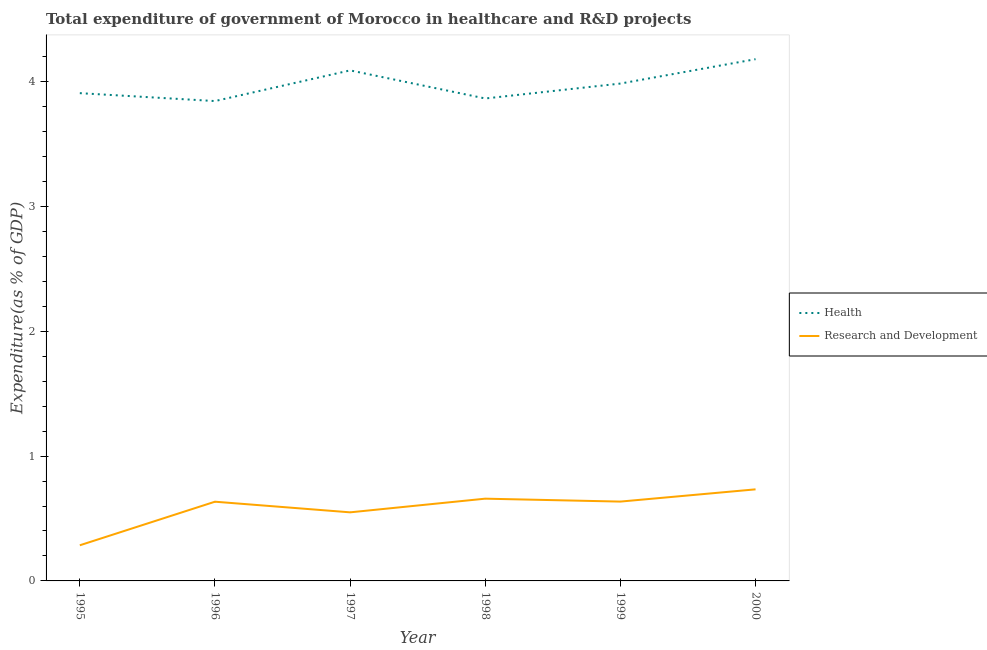What is the expenditure in healthcare in 1999?
Keep it short and to the point. 3.99. Across all years, what is the maximum expenditure in r&d?
Provide a short and direct response. 0.73. Across all years, what is the minimum expenditure in r&d?
Ensure brevity in your answer.  0.29. What is the total expenditure in healthcare in the graph?
Keep it short and to the point. 23.88. What is the difference between the expenditure in healthcare in 1998 and that in 2000?
Give a very brief answer. -0.31. What is the difference between the expenditure in r&d in 1998 and the expenditure in healthcare in 1999?
Ensure brevity in your answer.  -3.33. What is the average expenditure in healthcare per year?
Offer a very short reply. 3.98. In the year 1998, what is the difference between the expenditure in healthcare and expenditure in r&d?
Provide a short and direct response. 3.21. In how many years, is the expenditure in r&d greater than 0.6000000000000001 %?
Offer a terse response. 4. What is the ratio of the expenditure in healthcare in 1998 to that in 2000?
Make the answer very short. 0.92. What is the difference between the highest and the second highest expenditure in healthcare?
Make the answer very short. 0.09. What is the difference between the highest and the lowest expenditure in healthcare?
Make the answer very short. 0.34. In how many years, is the expenditure in r&d greater than the average expenditure in r&d taken over all years?
Your response must be concise. 4. Does the expenditure in healthcare monotonically increase over the years?
Give a very brief answer. No. Is the expenditure in healthcare strictly less than the expenditure in r&d over the years?
Make the answer very short. No. How many years are there in the graph?
Make the answer very short. 6. What is the difference between two consecutive major ticks on the Y-axis?
Give a very brief answer. 1. Where does the legend appear in the graph?
Your answer should be very brief. Center right. What is the title of the graph?
Offer a very short reply. Total expenditure of government of Morocco in healthcare and R&D projects. What is the label or title of the X-axis?
Your answer should be very brief. Year. What is the label or title of the Y-axis?
Offer a terse response. Expenditure(as % of GDP). What is the Expenditure(as % of GDP) of Health in 1995?
Offer a terse response. 3.91. What is the Expenditure(as % of GDP) of Research and Development in 1995?
Offer a very short reply. 0.29. What is the Expenditure(as % of GDP) in Health in 1996?
Provide a short and direct response. 3.84. What is the Expenditure(as % of GDP) in Research and Development in 1996?
Offer a very short reply. 0.63. What is the Expenditure(as % of GDP) in Health in 1997?
Your answer should be very brief. 4.09. What is the Expenditure(as % of GDP) of Research and Development in 1997?
Your answer should be compact. 0.55. What is the Expenditure(as % of GDP) of Health in 1998?
Your answer should be compact. 3.87. What is the Expenditure(as % of GDP) in Research and Development in 1998?
Your response must be concise. 0.66. What is the Expenditure(as % of GDP) of Health in 1999?
Your answer should be very brief. 3.99. What is the Expenditure(as % of GDP) in Research and Development in 1999?
Keep it short and to the point. 0.64. What is the Expenditure(as % of GDP) in Health in 2000?
Your response must be concise. 4.18. What is the Expenditure(as % of GDP) of Research and Development in 2000?
Your answer should be compact. 0.73. Across all years, what is the maximum Expenditure(as % of GDP) in Health?
Offer a very short reply. 4.18. Across all years, what is the maximum Expenditure(as % of GDP) of Research and Development?
Ensure brevity in your answer.  0.73. Across all years, what is the minimum Expenditure(as % of GDP) of Health?
Offer a very short reply. 3.84. Across all years, what is the minimum Expenditure(as % of GDP) in Research and Development?
Provide a succinct answer. 0.29. What is the total Expenditure(as % of GDP) of Health in the graph?
Provide a short and direct response. 23.88. What is the total Expenditure(as % of GDP) of Research and Development in the graph?
Your answer should be very brief. 3.5. What is the difference between the Expenditure(as % of GDP) in Health in 1995 and that in 1996?
Offer a very short reply. 0.06. What is the difference between the Expenditure(as % of GDP) of Research and Development in 1995 and that in 1996?
Your answer should be compact. -0.35. What is the difference between the Expenditure(as % of GDP) in Health in 1995 and that in 1997?
Offer a terse response. -0.18. What is the difference between the Expenditure(as % of GDP) in Research and Development in 1995 and that in 1997?
Give a very brief answer. -0.26. What is the difference between the Expenditure(as % of GDP) in Health in 1995 and that in 1998?
Offer a terse response. 0.04. What is the difference between the Expenditure(as % of GDP) of Research and Development in 1995 and that in 1998?
Your response must be concise. -0.37. What is the difference between the Expenditure(as % of GDP) in Health in 1995 and that in 1999?
Your answer should be very brief. -0.08. What is the difference between the Expenditure(as % of GDP) in Research and Development in 1995 and that in 1999?
Ensure brevity in your answer.  -0.35. What is the difference between the Expenditure(as % of GDP) of Health in 1995 and that in 2000?
Your answer should be very brief. -0.27. What is the difference between the Expenditure(as % of GDP) in Research and Development in 1995 and that in 2000?
Your response must be concise. -0.45. What is the difference between the Expenditure(as % of GDP) of Health in 1996 and that in 1997?
Give a very brief answer. -0.25. What is the difference between the Expenditure(as % of GDP) of Research and Development in 1996 and that in 1997?
Provide a short and direct response. 0.09. What is the difference between the Expenditure(as % of GDP) in Health in 1996 and that in 1998?
Your answer should be very brief. -0.02. What is the difference between the Expenditure(as % of GDP) of Research and Development in 1996 and that in 1998?
Offer a terse response. -0.02. What is the difference between the Expenditure(as % of GDP) in Health in 1996 and that in 1999?
Give a very brief answer. -0.14. What is the difference between the Expenditure(as % of GDP) in Research and Development in 1996 and that in 1999?
Your answer should be compact. -0. What is the difference between the Expenditure(as % of GDP) of Health in 1996 and that in 2000?
Your answer should be compact. -0.34. What is the difference between the Expenditure(as % of GDP) in Research and Development in 1996 and that in 2000?
Ensure brevity in your answer.  -0.1. What is the difference between the Expenditure(as % of GDP) of Health in 1997 and that in 1998?
Your response must be concise. 0.23. What is the difference between the Expenditure(as % of GDP) in Research and Development in 1997 and that in 1998?
Give a very brief answer. -0.11. What is the difference between the Expenditure(as % of GDP) in Health in 1997 and that in 1999?
Offer a very short reply. 0.11. What is the difference between the Expenditure(as % of GDP) of Research and Development in 1997 and that in 1999?
Offer a very short reply. -0.09. What is the difference between the Expenditure(as % of GDP) of Health in 1997 and that in 2000?
Provide a short and direct response. -0.09. What is the difference between the Expenditure(as % of GDP) of Research and Development in 1997 and that in 2000?
Your answer should be compact. -0.18. What is the difference between the Expenditure(as % of GDP) of Health in 1998 and that in 1999?
Provide a succinct answer. -0.12. What is the difference between the Expenditure(as % of GDP) of Research and Development in 1998 and that in 1999?
Keep it short and to the point. 0.02. What is the difference between the Expenditure(as % of GDP) in Health in 1998 and that in 2000?
Offer a terse response. -0.31. What is the difference between the Expenditure(as % of GDP) of Research and Development in 1998 and that in 2000?
Your answer should be very brief. -0.07. What is the difference between the Expenditure(as % of GDP) in Health in 1999 and that in 2000?
Keep it short and to the point. -0.2. What is the difference between the Expenditure(as % of GDP) of Research and Development in 1999 and that in 2000?
Your response must be concise. -0.1. What is the difference between the Expenditure(as % of GDP) in Health in 1995 and the Expenditure(as % of GDP) in Research and Development in 1996?
Provide a short and direct response. 3.27. What is the difference between the Expenditure(as % of GDP) of Health in 1995 and the Expenditure(as % of GDP) of Research and Development in 1997?
Make the answer very short. 3.36. What is the difference between the Expenditure(as % of GDP) of Health in 1995 and the Expenditure(as % of GDP) of Research and Development in 1998?
Keep it short and to the point. 3.25. What is the difference between the Expenditure(as % of GDP) of Health in 1995 and the Expenditure(as % of GDP) of Research and Development in 1999?
Offer a very short reply. 3.27. What is the difference between the Expenditure(as % of GDP) of Health in 1995 and the Expenditure(as % of GDP) of Research and Development in 2000?
Your response must be concise. 3.17. What is the difference between the Expenditure(as % of GDP) in Health in 1996 and the Expenditure(as % of GDP) in Research and Development in 1997?
Make the answer very short. 3.3. What is the difference between the Expenditure(as % of GDP) of Health in 1996 and the Expenditure(as % of GDP) of Research and Development in 1998?
Offer a very short reply. 3.19. What is the difference between the Expenditure(as % of GDP) of Health in 1996 and the Expenditure(as % of GDP) of Research and Development in 1999?
Ensure brevity in your answer.  3.21. What is the difference between the Expenditure(as % of GDP) of Health in 1996 and the Expenditure(as % of GDP) of Research and Development in 2000?
Give a very brief answer. 3.11. What is the difference between the Expenditure(as % of GDP) in Health in 1997 and the Expenditure(as % of GDP) in Research and Development in 1998?
Your answer should be very brief. 3.43. What is the difference between the Expenditure(as % of GDP) in Health in 1997 and the Expenditure(as % of GDP) in Research and Development in 1999?
Keep it short and to the point. 3.46. What is the difference between the Expenditure(as % of GDP) in Health in 1997 and the Expenditure(as % of GDP) in Research and Development in 2000?
Make the answer very short. 3.36. What is the difference between the Expenditure(as % of GDP) of Health in 1998 and the Expenditure(as % of GDP) of Research and Development in 1999?
Make the answer very short. 3.23. What is the difference between the Expenditure(as % of GDP) in Health in 1998 and the Expenditure(as % of GDP) in Research and Development in 2000?
Your response must be concise. 3.13. What is the difference between the Expenditure(as % of GDP) in Health in 1999 and the Expenditure(as % of GDP) in Research and Development in 2000?
Give a very brief answer. 3.25. What is the average Expenditure(as % of GDP) in Health per year?
Provide a succinct answer. 3.98. What is the average Expenditure(as % of GDP) in Research and Development per year?
Your answer should be compact. 0.58. In the year 1995, what is the difference between the Expenditure(as % of GDP) in Health and Expenditure(as % of GDP) in Research and Development?
Your answer should be very brief. 3.62. In the year 1996, what is the difference between the Expenditure(as % of GDP) of Health and Expenditure(as % of GDP) of Research and Development?
Keep it short and to the point. 3.21. In the year 1997, what is the difference between the Expenditure(as % of GDP) in Health and Expenditure(as % of GDP) in Research and Development?
Offer a terse response. 3.54. In the year 1998, what is the difference between the Expenditure(as % of GDP) of Health and Expenditure(as % of GDP) of Research and Development?
Your answer should be very brief. 3.21. In the year 1999, what is the difference between the Expenditure(as % of GDP) of Health and Expenditure(as % of GDP) of Research and Development?
Provide a short and direct response. 3.35. In the year 2000, what is the difference between the Expenditure(as % of GDP) of Health and Expenditure(as % of GDP) of Research and Development?
Ensure brevity in your answer.  3.45. What is the ratio of the Expenditure(as % of GDP) of Health in 1995 to that in 1996?
Keep it short and to the point. 1.02. What is the ratio of the Expenditure(as % of GDP) in Research and Development in 1995 to that in 1996?
Provide a succinct answer. 0.45. What is the ratio of the Expenditure(as % of GDP) in Health in 1995 to that in 1997?
Keep it short and to the point. 0.96. What is the ratio of the Expenditure(as % of GDP) in Research and Development in 1995 to that in 1997?
Keep it short and to the point. 0.52. What is the ratio of the Expenditure(as % of GDP) in Health in 1995 to that in 1998?
Your answer should be compact. 1.01. What is the ratio of the Expenditure(as % of GDP) of Research and Development in 1995 to that in 1998?
Your response must be concise. 0.43. What is the ratio of the Expenditure(as % of GDP) of Health in 1995 to that in 1999?
Offer a very short reply. 0.98. What is the ratio of the Expenditure(as % of GDP) in Research and Development in 1995 to that in 1999?
Keep it short and to the point. 0.45. What is the ratio of the Expenditure(as % of GDP) of Health in 1995 to that in 2000?
Your answer should be very brief. 0.93. What is the ratio of the Expenditure(as % of GDP) in Research and Development in 1995 to that in 2000?
Make the answer very short. 0.39. What is the ratio of the Expenditure(as % of GDP) of Health in 1996 to that in 1997?
Give a very brief answer. 0.94. What is the ratio of the Expenditure(as % of GDP) in Research and Development in 1996 to that in 1997?
Provide a short and direct response. 1.16. What is the ratio of the Expenditure(as % of GDP) in Research and Development in 1996 to that in 1998?
Offer a terse response. 0.96. What is the ratio of the Expenditure(as % of GDP) in Health in 1996 to that in 1999?
Offer a terse response. 0.96. What is the ratio of the Expenditure(as % of GDP) of Health in 1996 to that in 2000?
Provide a short and direct response. 0.92. What is the ratio of the Expenditure(as % of GDP) of Research and Development in 1996 to that in 2000?
Make the answer very short. 0.86. What is the ratio of the Expenditure(as % of GDP) of Health in 1997 to that in 1998?
Provide a succinct answer. 1.06. What is the ratio of the Expenditure(as % of GDP) in Research and Development in 1997 to that in 1998?
Ensure brevity in your answer.  0.83. What is the ratio of the Expenditure(as % of GDP) in Health in 1997 to that in 1999?
Provide a succinct answer. 1.03. What is the ratio of the Expenditure(as % of GDP) of Research and Development in 1997 to that in 1999?
Provide a succinct answer. 0.86. What is the ratio of the Expenditure(as % of GDP) of Health in 1997 to that in 2000?
Keep it short and to the point. 0.98. What is the ratio of the Expenditure(as % of GDP) of Research and Development in 1997 to that in 2000?
Ensure brevity in your answer.  0.75. What is the ratio of the Expenditure(as % of GDP) of Health in 1998 to that in 1999?
Give a very brief answer. 0.97. What is the ratio of the Expenditure(as % of GDP) in Research and Development in 1998 to that in 1999?
Your answer should be very brief. 1.04. What is the ratio of the Expenditure(as % of GDP) of Health in 1998 to that in 2000?
Offer a very short reply. 0.92. What is the ratio of the Expenditure(as % of GDP) in Research and Development in 1998 to that in 2000?
Offer a terse response. 0.9. What is the ratio of the Expenditure(as % of GDP) of Health in 1999 to that in 2000?
Offer a terse response. 0.95. What is the ratio of the Expenditure(as % of GDP) of Research and Development in 1999 to that in 2000?
Make the answer very short. 0.87. What is the difference between the highest and the second highest Expenditure(as % of GDP) in Health?
Provide a succinct answer. 0.09. What is the difference between the highest and the second highest Expenditure(as % of GDP) in Research and Development?
Make the answer very short. 0.07. What is the difference between the highest and the lowest Expenditure(as % of GDP) of Health?
Provide a succinct answer. 0.34. What is the difference between the highest and the lowest Expenditure(as % of GDP) of Research and Development?
Offer a very short reply. 0.45. 